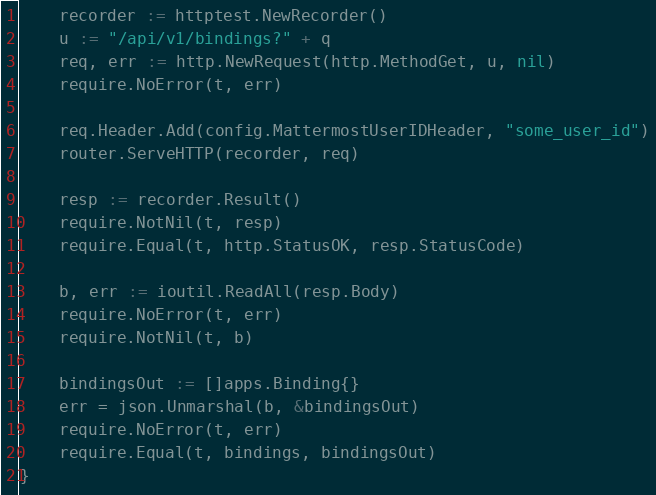Convert code to text. <code><loc_0><loc_0><loc_500><loc_500><_Go_>	recorder := httptest.NewRecorder()
	u := "/api/v1/bindings?" + q
	req, err := http.NewRequest(http.MethodGet, u, nil)
	require.NoError(t, err)

	req.Header.Add(config.MattermostUserIDHeader, "some_user_id")
	router.ServeHTTP(recorder, req)

	resp := recorder.Result()
	require.NotNil(t, resp)
	require.Equal(t, http.StatusOK, resp.StatusCode)

	b, err := ioutil.ReadAll(resp.Body)
	require.NoError(t, err)
	require.NotNil(t, b)

	bindingsOut := []apps.Binding{}
	err = json.Unmarshal(b, &bindingsOut)
	require.NoError(t, err)
	require.Equal(t, bindings, bindingsOut)
}
</code> 